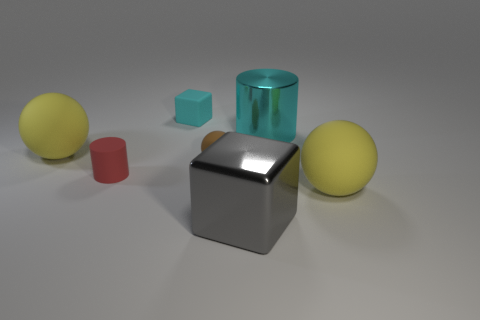What material is the thing that is the same color as the small rubber cube?
Your answer should be very brief. Metal. What size is the matte object that is the same shape as the gray metal thing?
Offer a terse response. Small. How many other things are the same color as the small matte sphere?
Offer a very short reply. 0. How many cylinders are big yellow objects or tiny red matte objects?
Offer a terse response. 1. The tiny matte sphere on the right side of the tiny thing that is left of the cyan rubber object is what color?
Make the answer very short. Brown. The small cyan matte object is what shape?
Keep it short and to the point. Cube. Do the yellow matte sphere that is to the left of the cyan metal cylinder and the rubber block have the same size?
Provide a succinct answer. No. Are there any brown balls made of the same material as the small cube?
Your answer should be compact. Yes. What number of things are objects that are left of the large shiny block or gray metallic blocks?
Provide a short and direct response. 5. Are any green rubber cylinders visible?
Offer a terse response. No. 